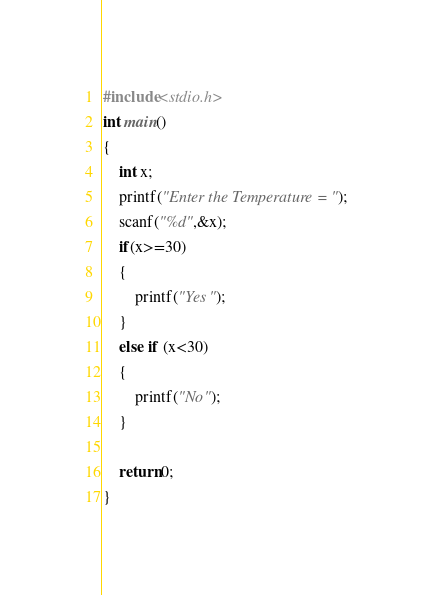Convert code to text. <code><loc_0><loc_0><loc_500><loc_500><_C_>#include<stdio.h>
int main()
{
    int x;
    printf("Enter the Temperature = ");
    scanf("%d",&x);
    if(x>=30)
    {
        printf("Yes");
    }
    else if (x<30)
    {
        printf("No");
    }

    return 0;
}
</code> 